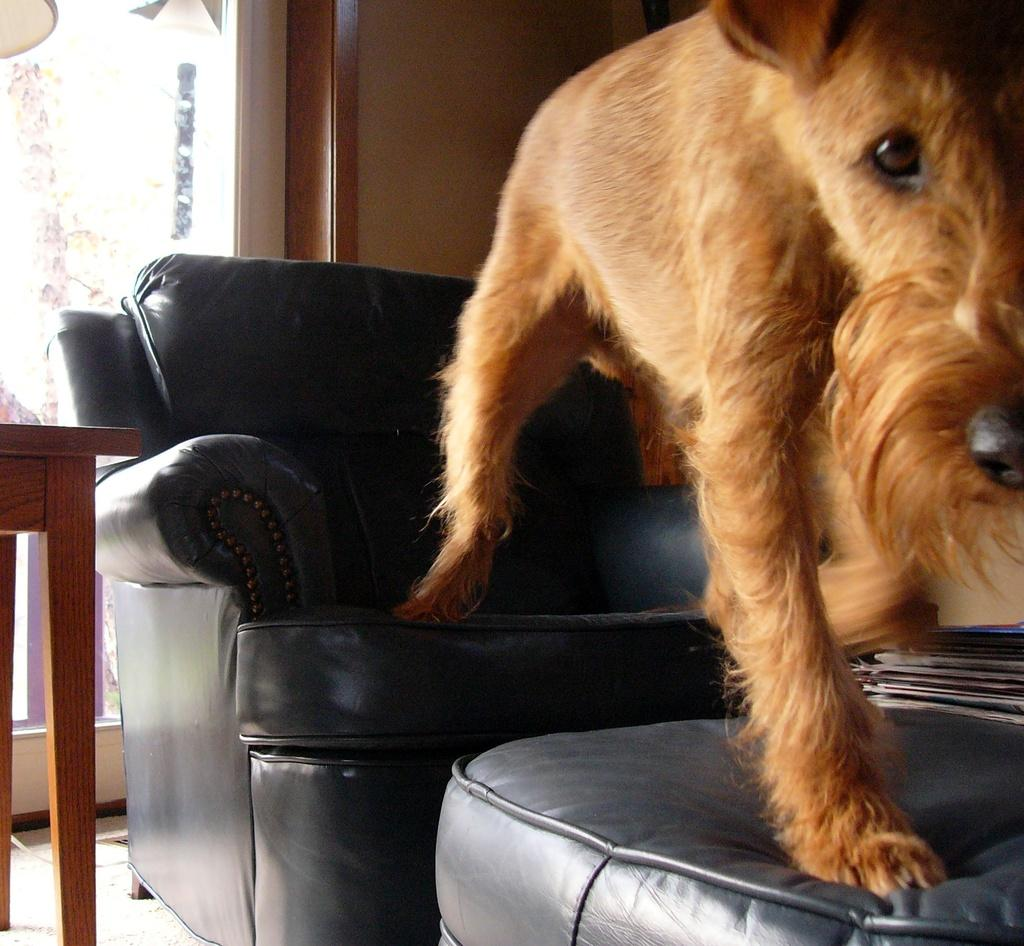What type of furniture is present in the image? There is a sofa in the image. Can you describe the arrangement of the furniture in the image? There is a table behind the sofa in the image. What other living organism can be seen in the image? There is an animal in the image. What type of comb is being used by the animal in the image? There is no comb present in the image, nor is there any indication that the animal is using one. 